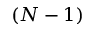<formula> <loc_0><loc_0><loc_500><loc_500>( N - 1 )</formula> 